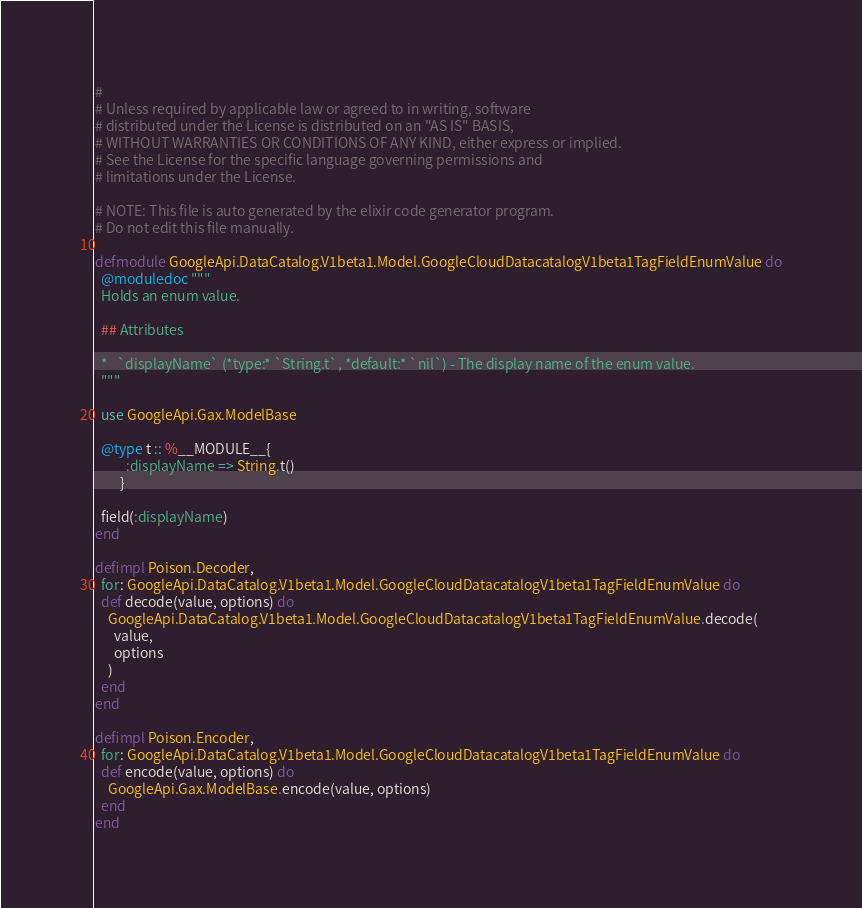Convert code to text. <code><loc_0><loc_0><loc_500><loc_500><_Elixir_>#
# Unless required by applicable law or agreed to in writing, software
# distributed under the License is distributed on an "AS IS" BASIS,
# WITHOUT WARRANTIES OR CONDITIONS OF ANY KIND, either express or implied.
# See the License for the specific language governing permissions and
# limitations under the License.

# NOTE: This file is auto generated by the elixir code generator program.
# Do not edit this file manually.

defmodule GoogleApi.DataCatalog.V1beta1.Model.GoogleCloudDatacatalogV1beta1TagFieldEnumValue do
  @moduledoc """
  Holds an enum value.

  ## Attributes

  *   `displayName` (*type:* `String.t`, *default:* `nil`) - The display name of the enum value.
  """

  use GoogleApi.Gax.ModelBase

  @type t :: %__MODULE__{
          :displayName => String.t()
        }

  field(:displayName)
end

defimpl Poison.Decoder,
  for: GoogleApi.DataCatalog.V1beta1.Model.GoogleCloudDatacatalogV1beta1TagFieldEnumValue do
  def decode(value, options) do
    GoogleApi.DataCatalog.V1beta1.Model.GoogleCloudDatacatalogV1beta1TagFieldEnumValue.decode(
      value,
      options
    )
  end
end

defimpl Poison.Encoder,
  for: GoogleApi.DataCatalog.V1beta1.Model.GoogleCloudDatacatalogV1beta1TagFieldEnumValue do
  def encode(value, options) do
    GoogleApi.Gax.ModelBase.encode(value, options)
  end
end
</code> 